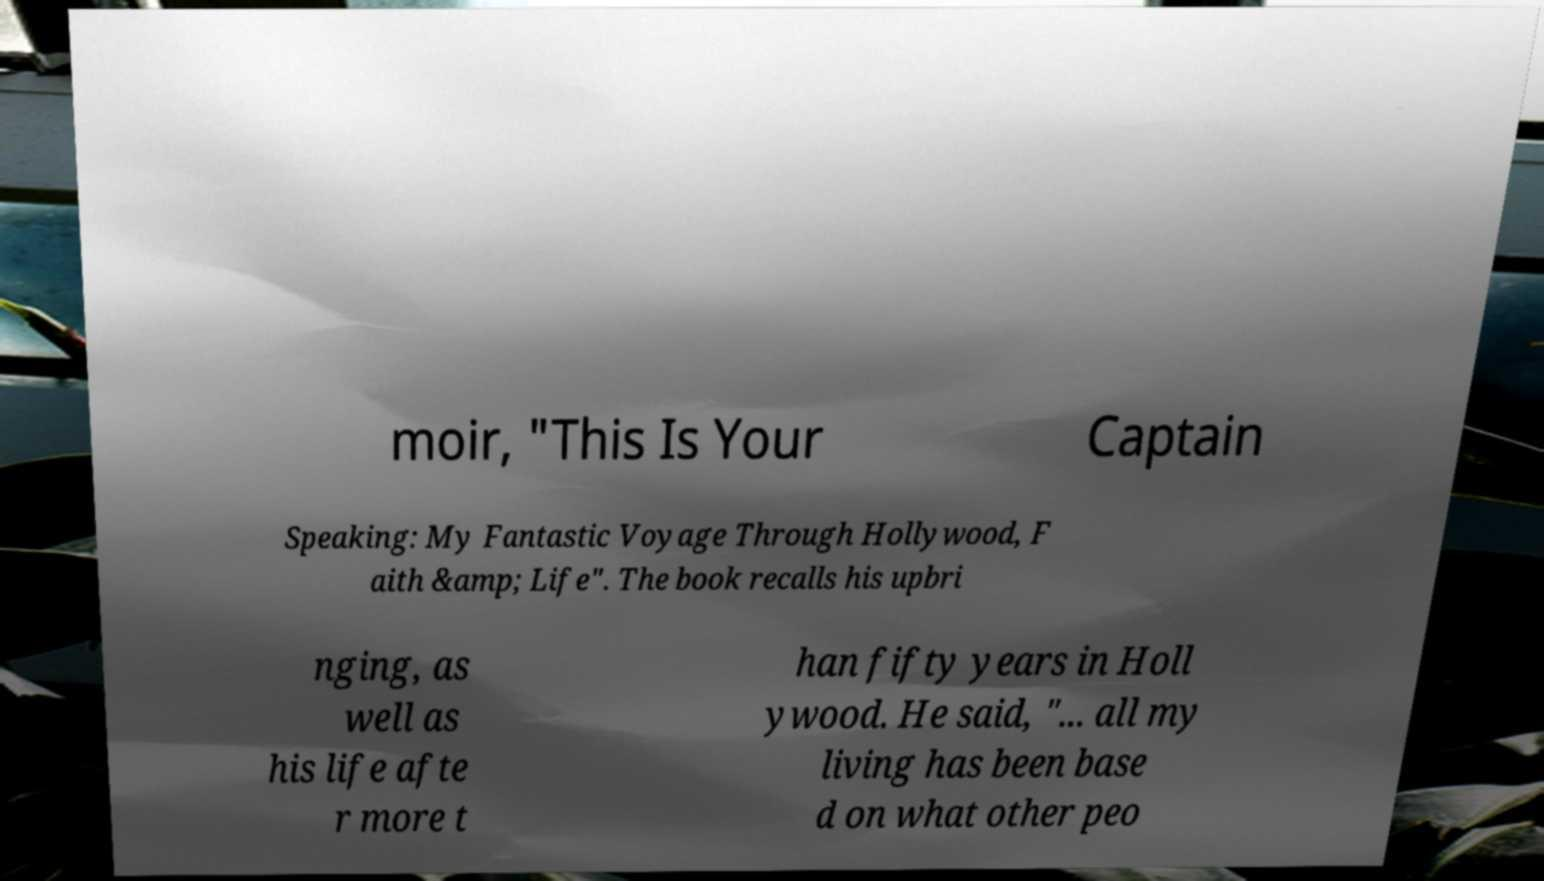Please identify and transcribe the text found in this image. moir, "This Is Your Captain Speaking: My Fantastic Voyage Through Hollywood, F aith &amp; Life". The book recalls his upbri nging, as well as his life afte r more t han fifty years in Holl ywood. He said, "... all my living has been base d on what other peo 